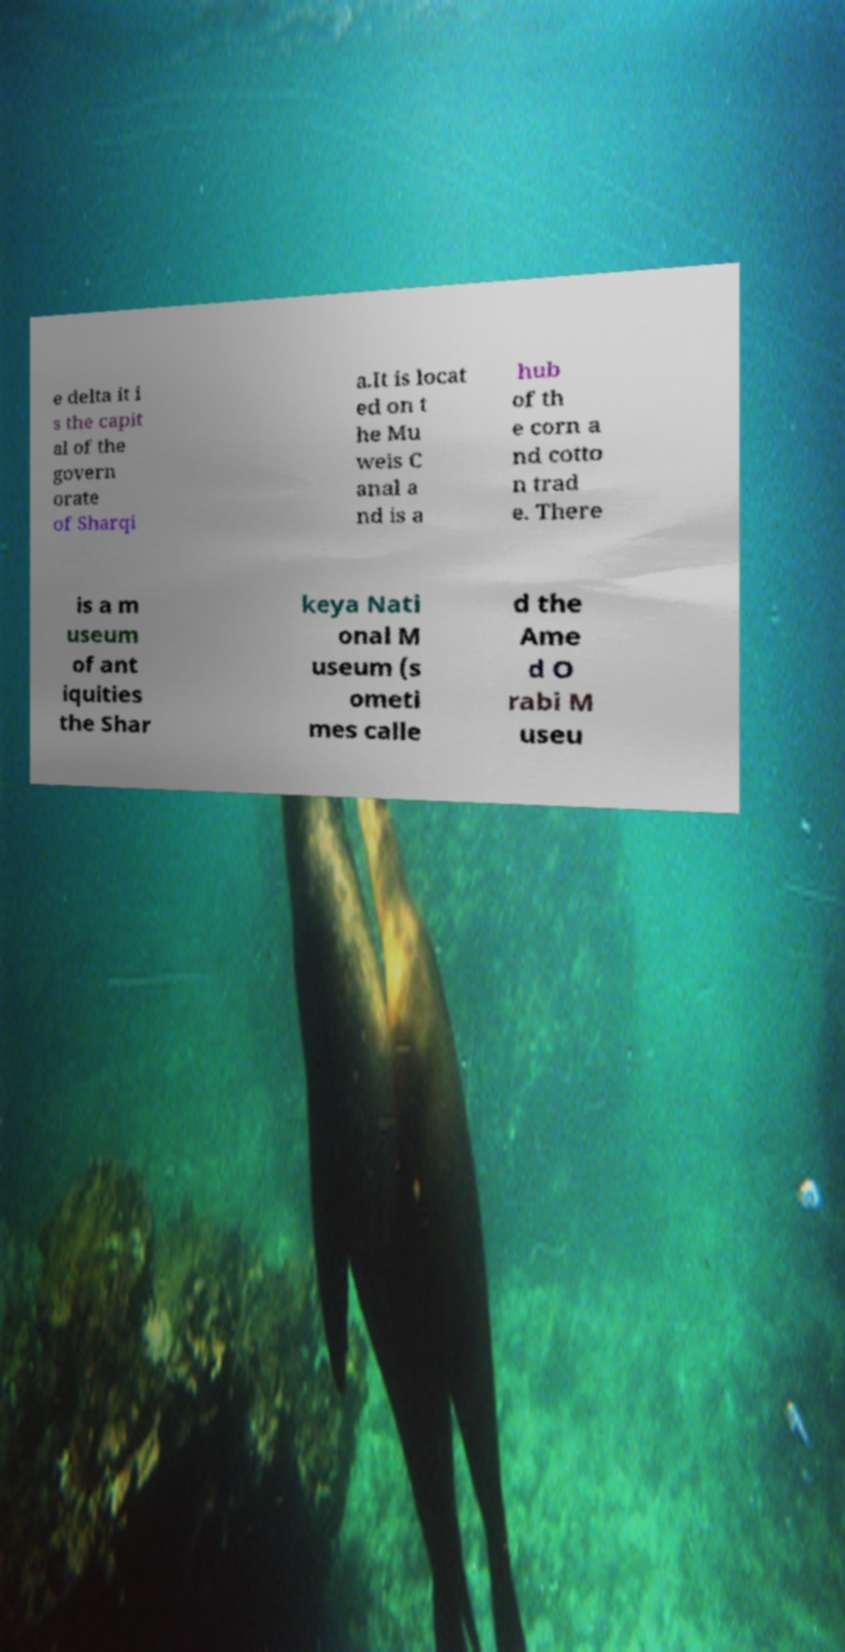There's text embedded in this image that I need extracted. Can you transcribe it verbatim? e delta it i s the capit al of the govern orate of Sharqi a.It is locat ed on t he Mu weis C anal a nd is a hub of th e corn a nd cotto n trad e. There is a m useum of ant iquities the Shar keya Nati onal M useum (s ometi mes calle d the Ame d O rabi M useu 